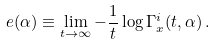<formula> <loc_0><loc_0><loc_500><loc_500>e ( \alpha ) \equiv \lim _ { t \to \infty } - \frac { 1 } { t } \log \Gamma ^ { i } _ { x } ( t , \alpha ) \, .</formula> 